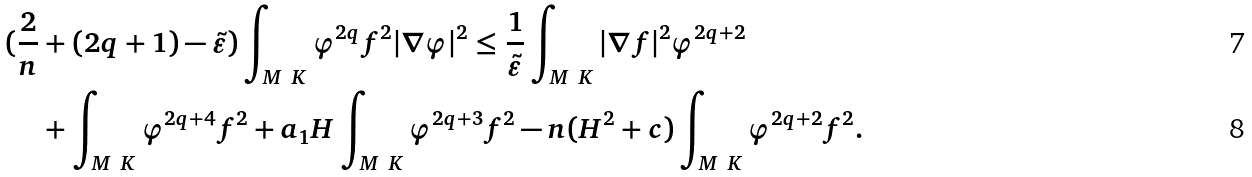Convert formula to latex. <formula><loc_0><loc_0><loc_500><loc_500>( \frac { 2 } { n } & + ( 2 q + 1 ) - \tilde { \varepsilon } ) \int _ { M \ K } \varphi ^ { 2 q } f ^ { 2 } | \nabla \varphi | ^ { 2 } \leq \frac { 1 } { \tilde { \varepsilon } } \int _ { M \ K } | \nabla f | ^ { 2 } \varphi ^ { 2 q + 2 } \\ & + \int _ { M \ K } \varphi ^ { 2 q + 4 } f ^ { 2 } + a _ { 1 } H \int _ { M \ K } \varphi ^ { 2 q + 3 } f ^ { 2 } - n ( H ^ { 2 } + c ) \int _ { M \ K } \varphi ^ { 2 q + 2 } f ^ { 2 } .</formula> 